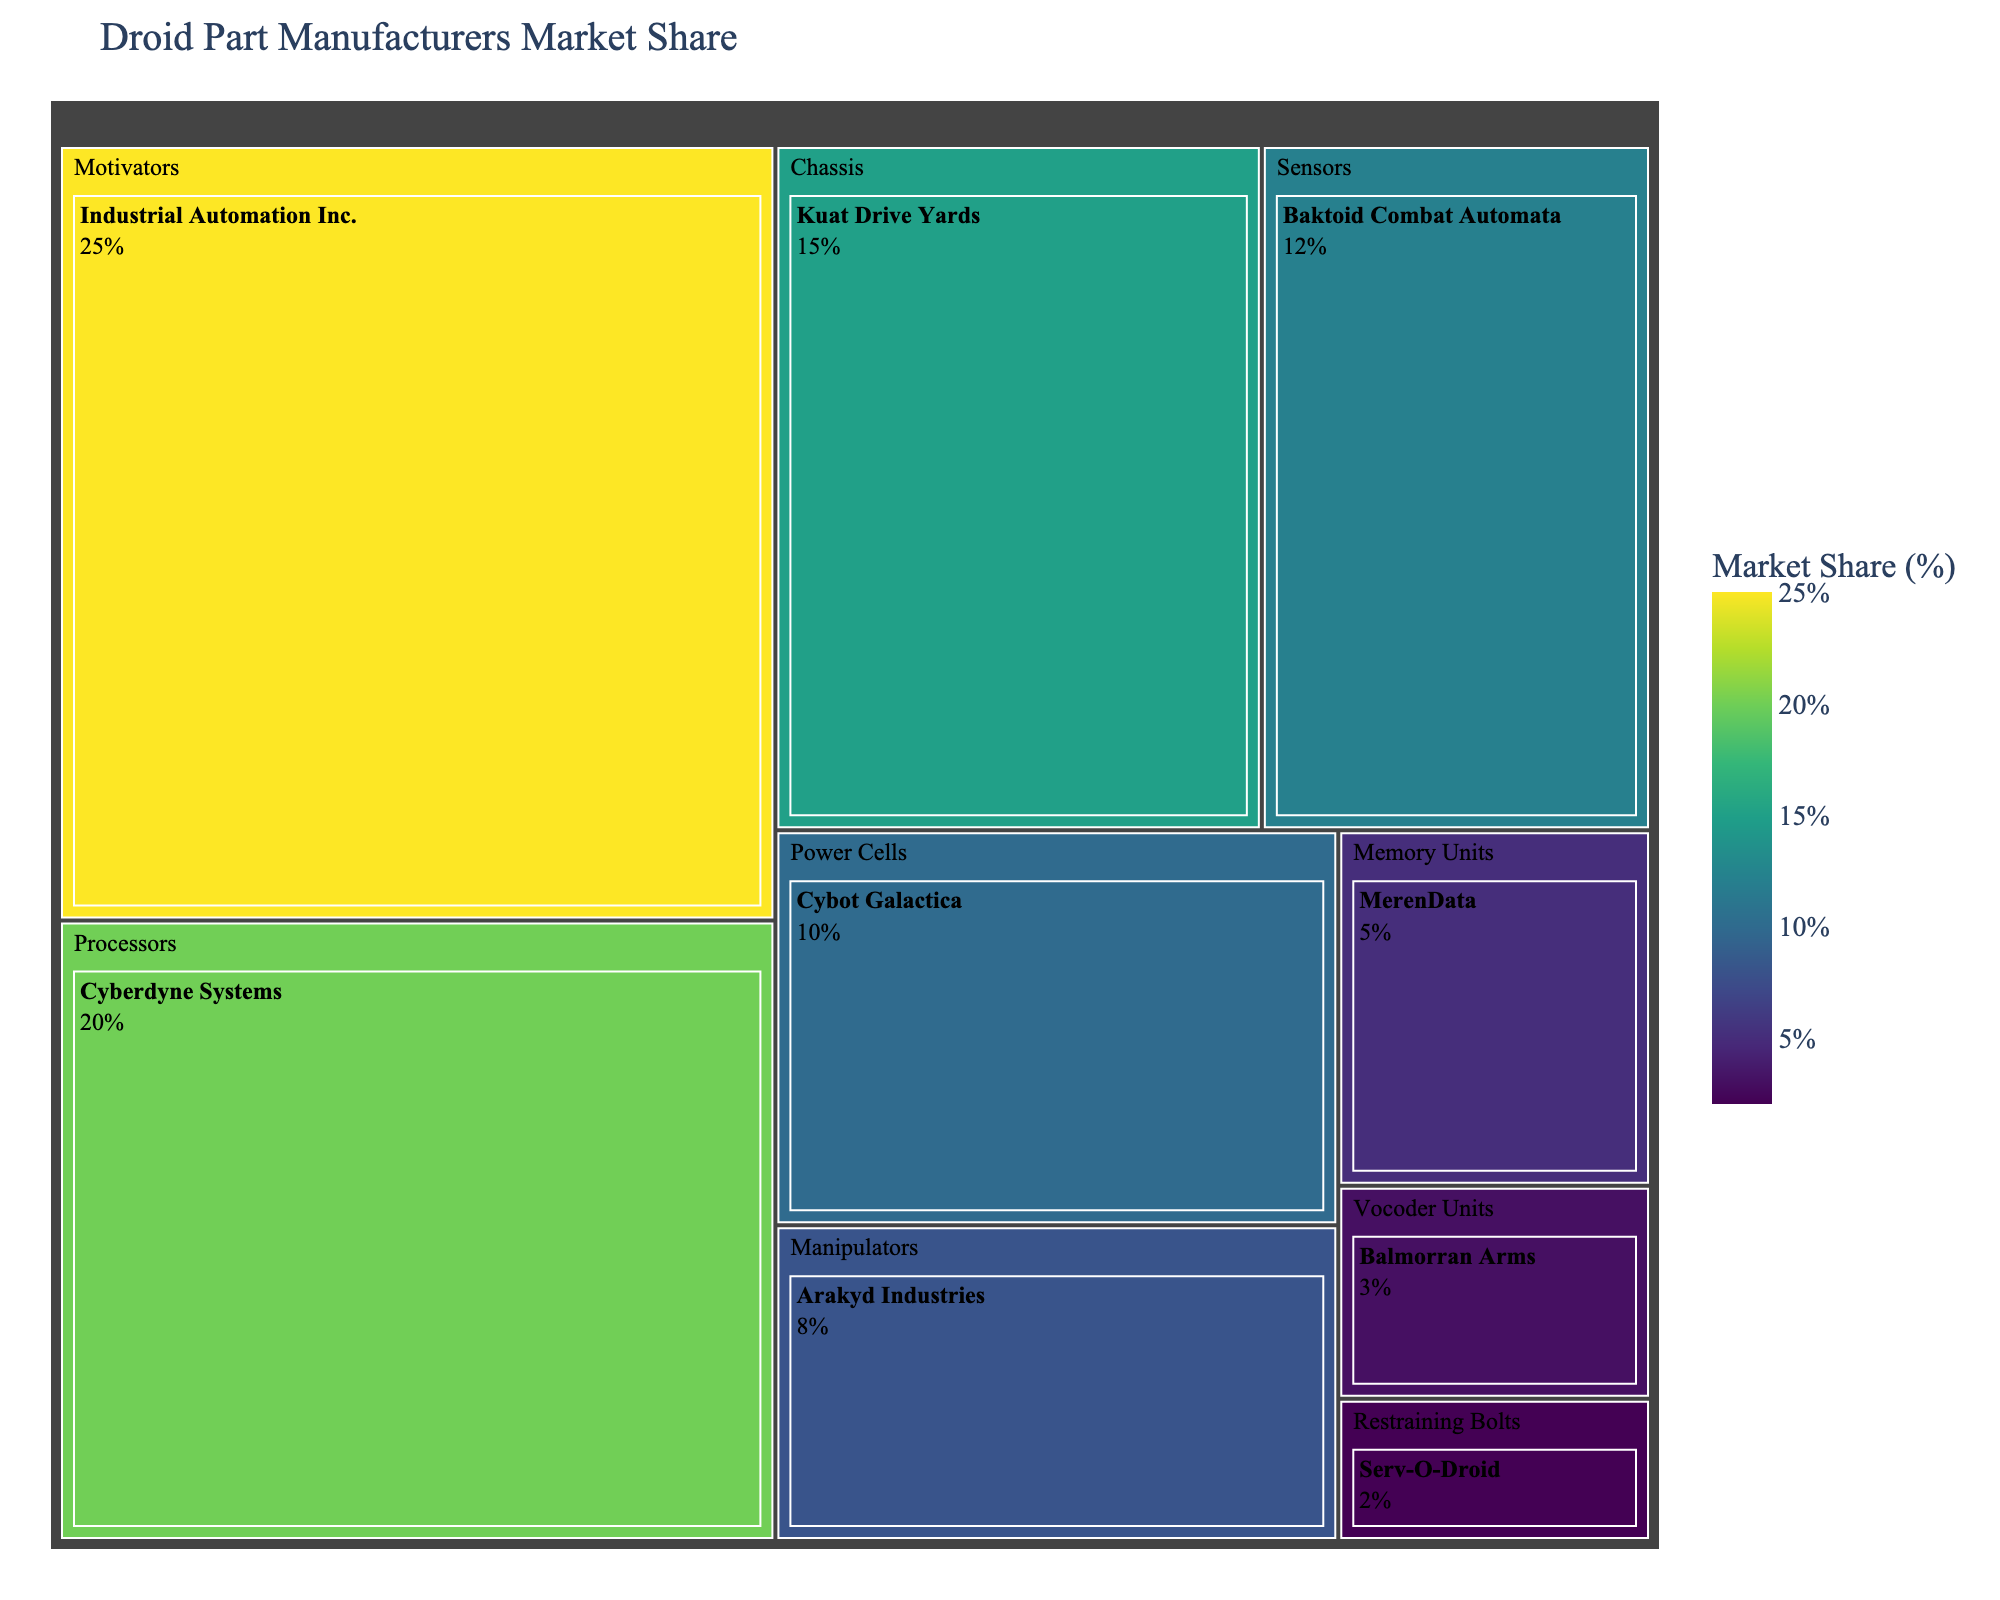What's the title of the treemap? The title of the chart is usually displayed at the top of the figure. In this case, the title given in the code is 'Droid Part Manufacturers Market Share'.
Answer: Droid Part Manufacturers Market Share Which manufacturer has the largest market share for droid parts? To find the manufacturer with the largest market share, look for the largest segment in the treemap. 'Industrial Automation Inc.' has the largest market share.
Answer: Industrial Automation Inc What color represents the highest market share on the treemap? The color for the highest market share can be determined by checking the color scale legend. The highest values are represented by a shade of yellow.
Answer: Yellow How many categories of droid parts are there? Count the different categories in the treemap. Here, they are 'Motivators', 'Processors', 'Chassis', 'Sensors', 'Power Cells', 'Manipulators', 'Memory Units', 'Vocoder Units', and 'Restraining Bolts', making a total of 9 categories.
Answer: 9 What is the combined market share of Cyberdyne Systems and Kuat Drive Yards? Add the market share percentages of Cyberdyne Systems (20%) and Kuat Drive Yards (15%). The combined market share is 20% + 15% = 35%.
Answer: 35% Which category has the lowest market share and what is it? The category with the lowest market share has the smallest segment in the treemap. 'Restraining Bolts' have the market share of 2%.
Answer: Restraining Bolts, 2% Compare the market share of Cybot Galactica and Arakyd Industries. Which one has a greater share? Look at the segments for Cybot Galactica and Arakyd Industries. Cybot Galactica has a market share of 10% while Arakyd Industries has 8%. Therefore, Cybot Galactica has a higher market share.
Answer: Cybot Galactica What is the market share of the manufacturer with the highest share in the 'Sensors' category? Identify the largest segment within the 'Sensors' category. Baktoid Combat Automata is the manufacturer in this category with the highest market share of 12%.
Answer: 12% What colors represent the market shares for the manufacturers in the 'Chassis' category? Locate the 'Chassis' category and observe the associated colors. Kuat Drive Yards, which is in the 'Chassis' category, has a market share represented by a shade of blue.
Answer: Blue Which three manufacturers have the smallest market shares, and what are their respective shares? Identify the smallest three segments in the treemap. The manufacturers with the smallest market shares are Serv-O-Droid (2%), Balmorran Arms (3%), and MerenData (5%).
Answer: Serv-O-Droid (2%), Balmorran Arms (3%), MerenData (5%) 